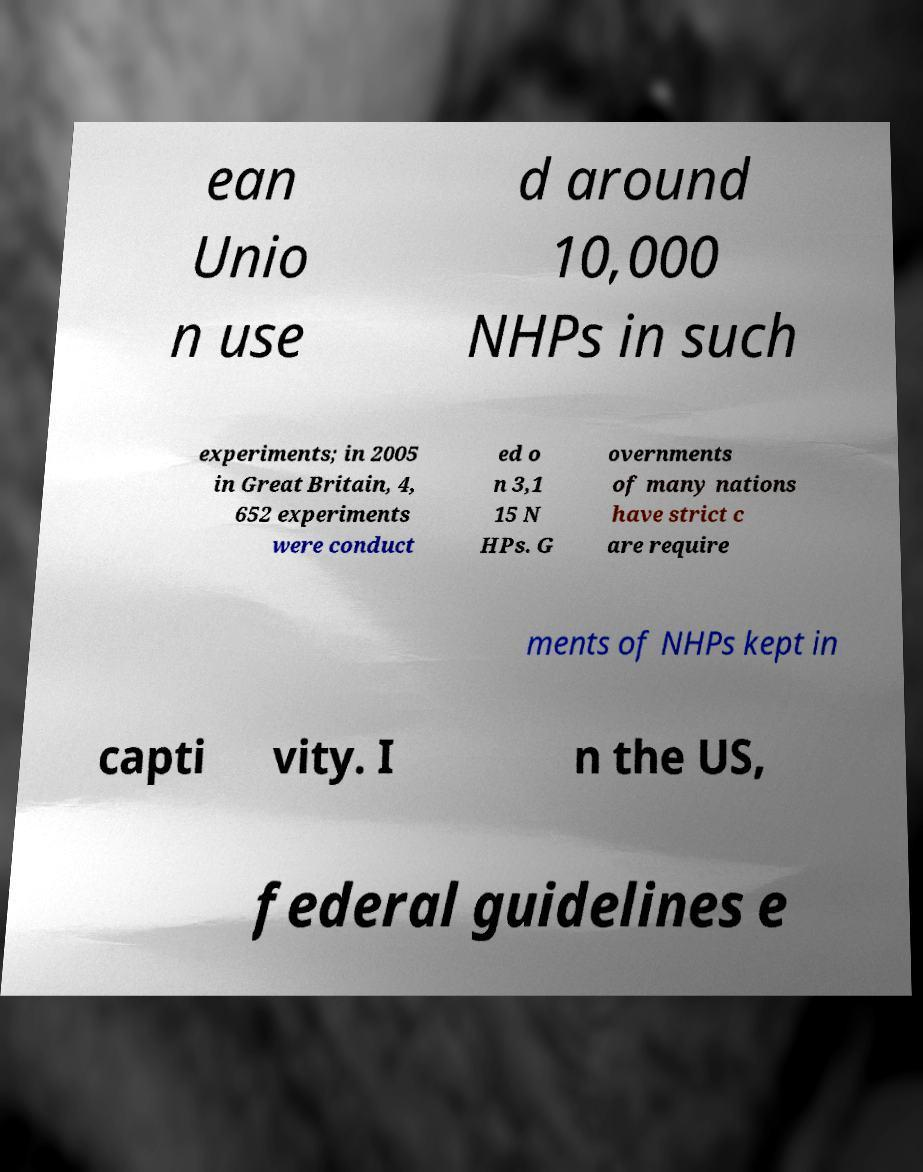Can you read and provide the text displayed in the image?This photo seems to have some interesting text. Can you extract and type it out for me? ean Unio n use d around 10,000 NHPs in such experiments; in 2005 in Great Britain, 4, 652 experiments were conduct ed o n 3,1 15 N HPs. G overnments of many nations have strict c are require ments of NHPs kept in capti vity. I n the US, federal guidelines e 